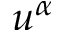<formula> <loc_0><loc_0><loc_500><loc_500>u ^ { \alpha }</formula> 